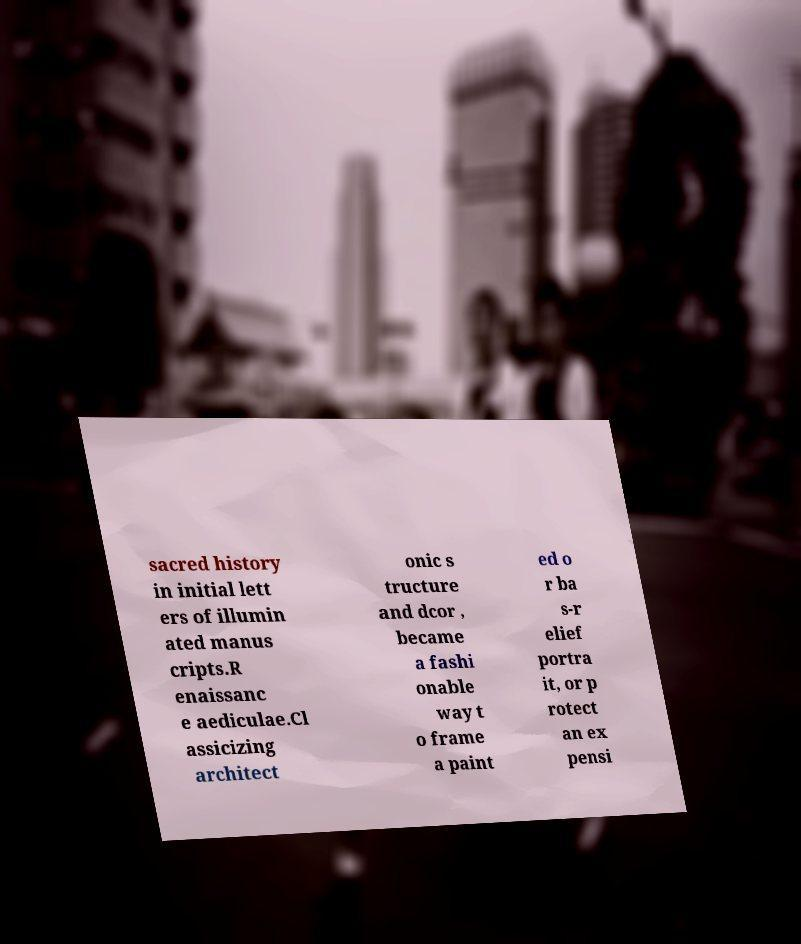For documentation purposes, I need the text within this image transcribed. Could you provide that? sacred history in initial lett ers of illumin ated manus cripts.R enaissanc e aediculae.Cl assicizing architect onic s tructure and dcor , became a fashi onable way t o frame a paint ed o r ba s-r elief portra it, or p rotect an ex pensi 